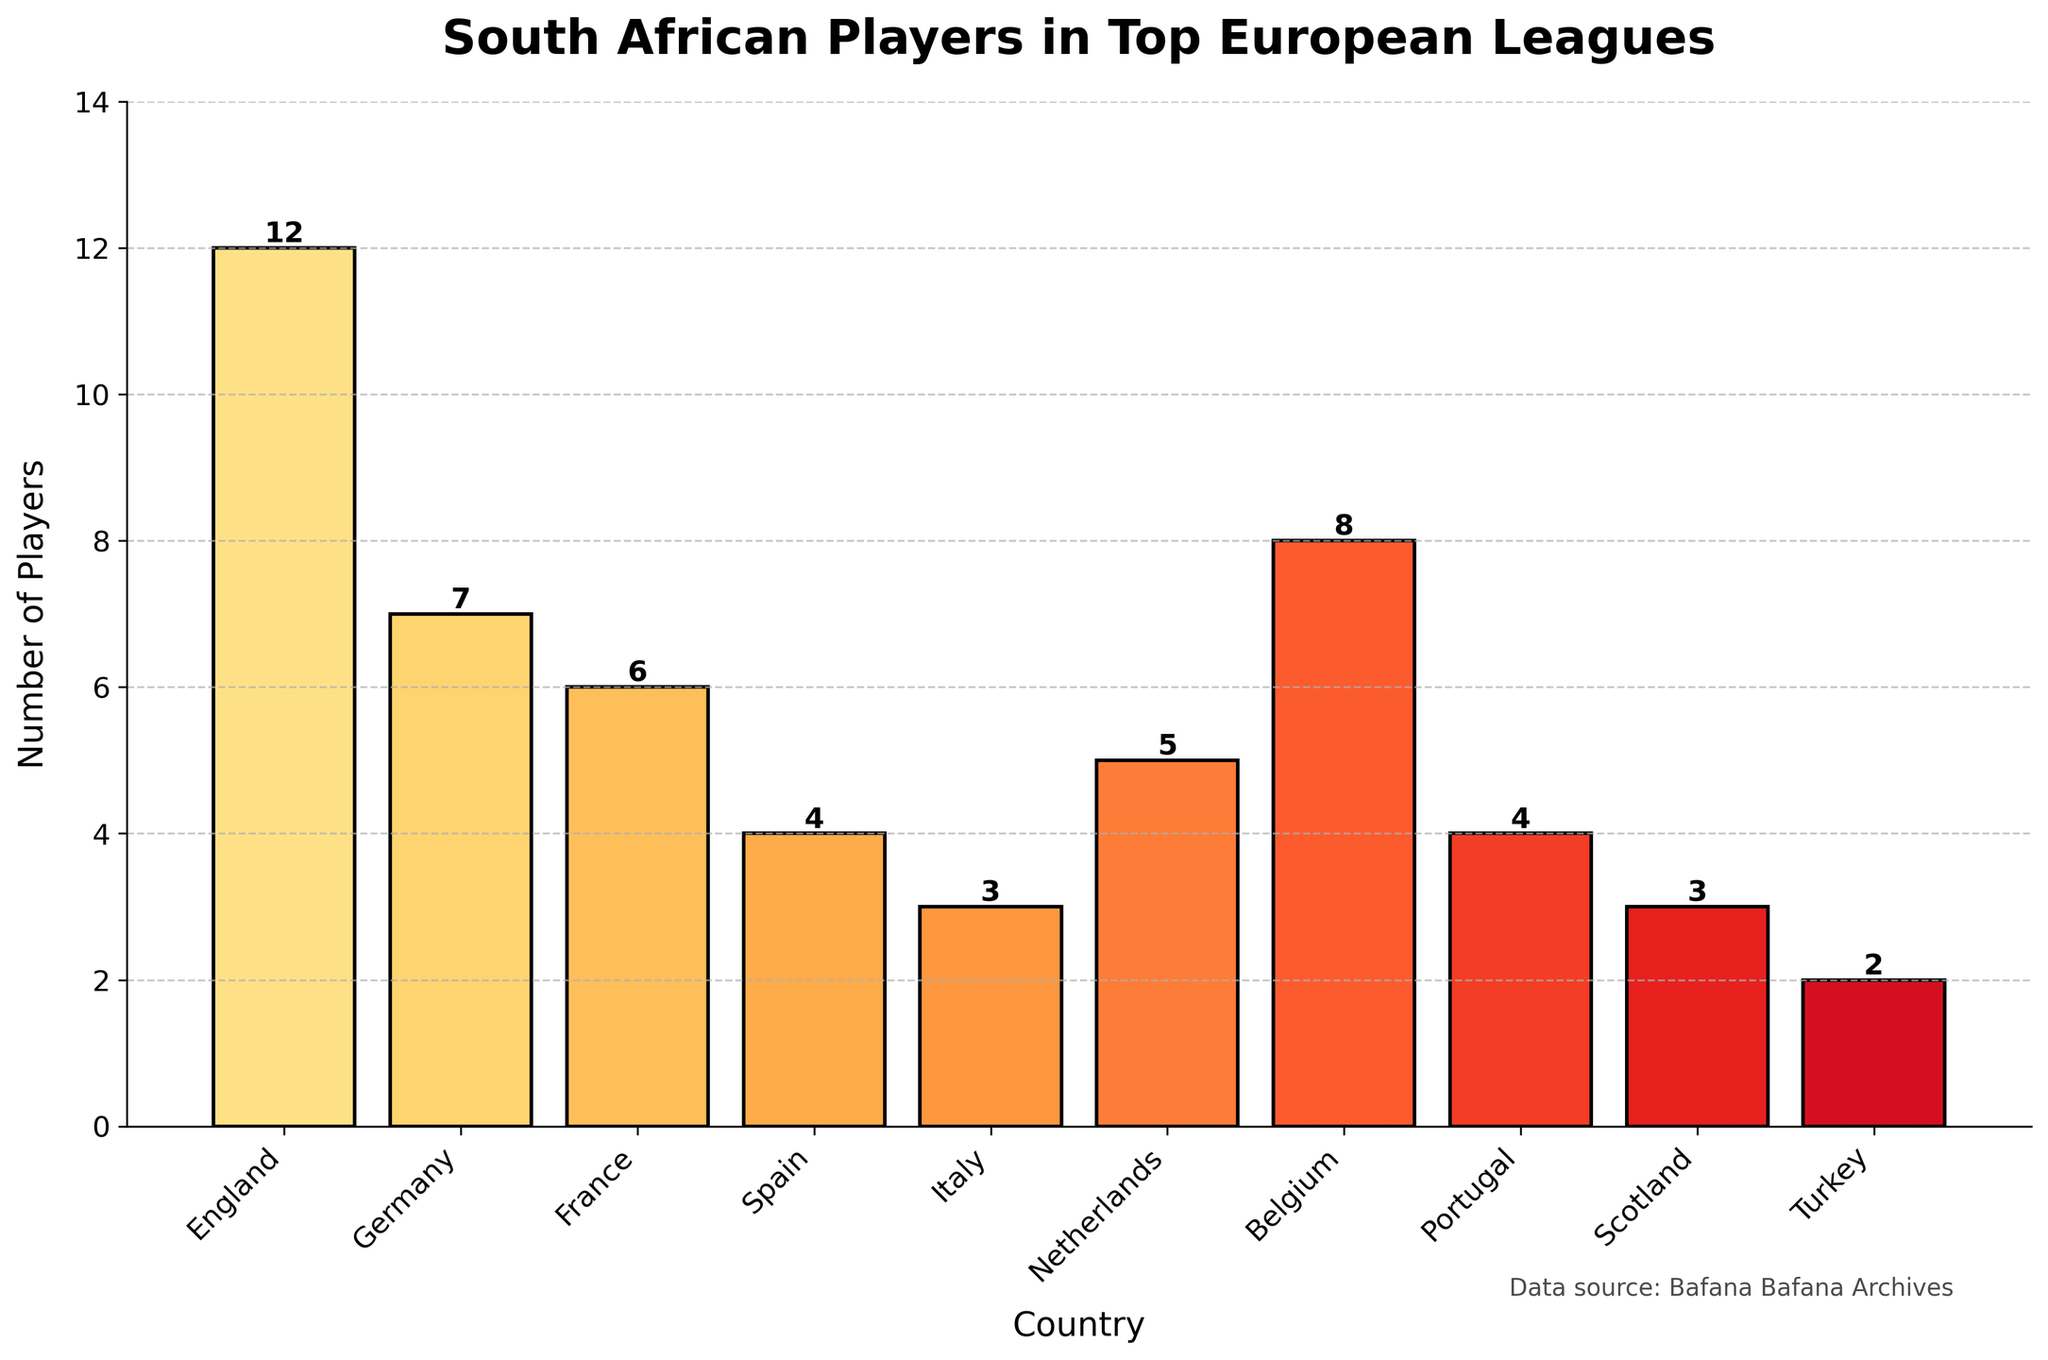Which country has the highest number of South African players in top European leagues? The bar representing England is the tallest, indicating it has the highest number of players.
Answer: England Which country has fewer South African players: Spain or Italy? The bars for Spain and Italy show 4 and 3 players respectively. Since 3 is less than 4, Italy has fewer players.
Answer: Italy How many South African players are in the top European leagues in total? Sum of all the players (12 + 7 + 6 + 4 + 3 + 5 + 8 + 4 + 3 + 2) = 54.
Answer: 54 What is the difference in the number of South African players in England and Belgium? England has 12 players and Belgium has 8 players. The difference is 12 - 8 = 4.
Answer: 4 Which countries have the same number of South African players? The bars for Spain and Portugal indicate both have 4 players each, and the bars for Italy and Scotland show both have 3 players each.
Answer: Spain and Portugal; Italy and Scotland Is the number of South African players in Germany greater than or less than those in Belgium? The bar for Germany shows 7 players, and the bar for Belgium shows 8 players. 7 is less than 8.
Answer: Less than What’s the average number of South African players in the listed countries? Sum the total players, which is 54, and divide by the number of countries (10): 54 / 10 = 5.4.
Answer: 5.4 Which country has more South African players: Netherlands or France? The bar for Netherlands shows 5 players, and the bar for France shows 6 players. 6 is more than 5.
Answer: France What two countries combined have the same number of South African players as Germany? Turkey with 2 and Belgium with 8 combined give 2 + 8 = 10 players.
Answer: Turkey and Belgium Is the height of the bar for Turkey shorter or taller than the one for Scotland? The bar for Turkey shows 2 players, and the bar for Scotland shows 3 players. Therefore, the bar for Turkey is shorter.
Answer: Shorter 